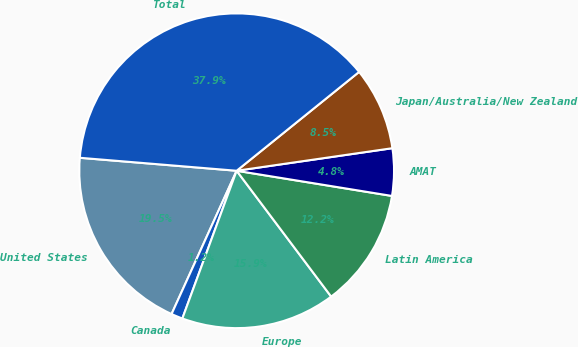Convert chart. <chart><loc_0><loc_0><loc_500><loc_500><pie_chart><fcel>United States<fcel>Canada<fcel>Europe<fcel>Latin America<fcel>AMAT<fcel>Japan/Australia/New Zealand<fcel>Total<nl><fcel>19.53%<fcel>1.18%<fcel>15.86%<fcel>12.19%<fcel>4.85%<fcel>8.52%<fcel>37.88%<nl></chart> 